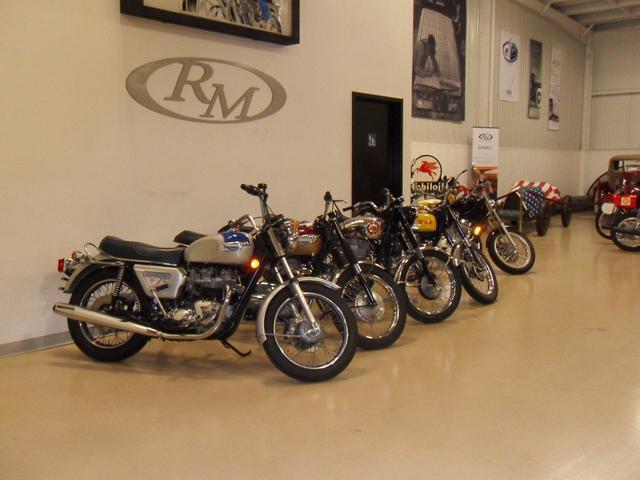How many motorbikes?
Give a very brief answer. 7. How many bikes are seen?
Give a very brief answer. 5. How many bikes are there?
Give a very brief answer. 7. How many bikes are in the photo?
Give a very brief answer. 7. How many motorcycles are in the photo?
Give a very brief answer. 6. How many motorcycles are there?
Give a very brief answer. 5. How many motorcycles can you see?
Give a very brief answer. 5. How many chairs are on the left side of the table?
Give a very brief answer. 0. 